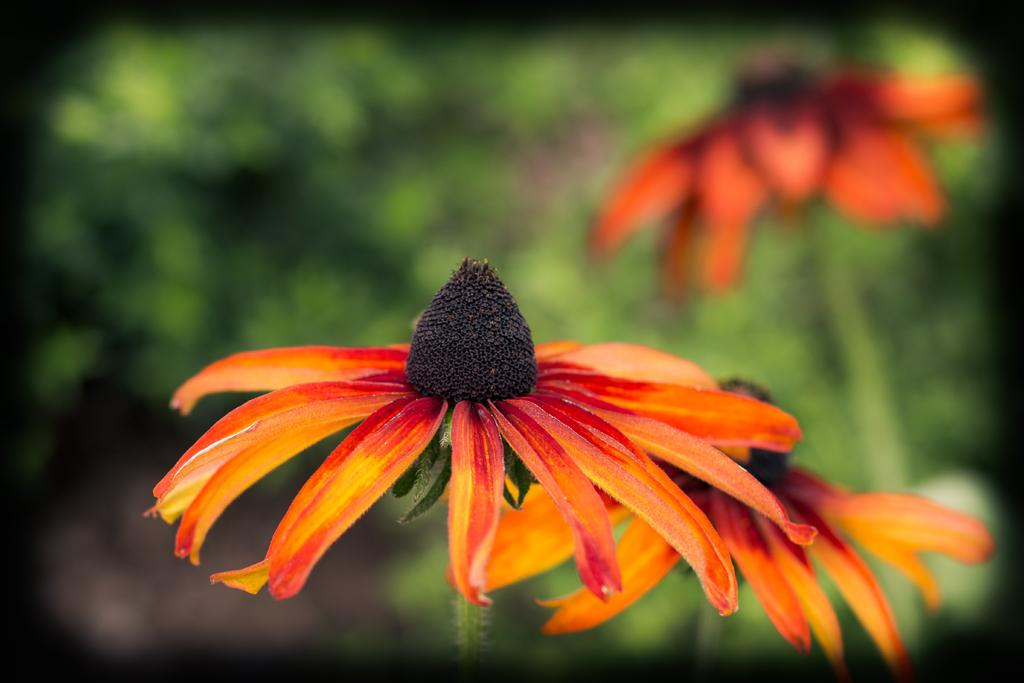How many flowers are present in the image? There are three flowers in the image. Can you describe the background of the image? The background of the image is blurry. What type of cloth is being used to clean the oil in the image? There is no cloth or oil present in the image; it only features three flowers with a blurry background. 